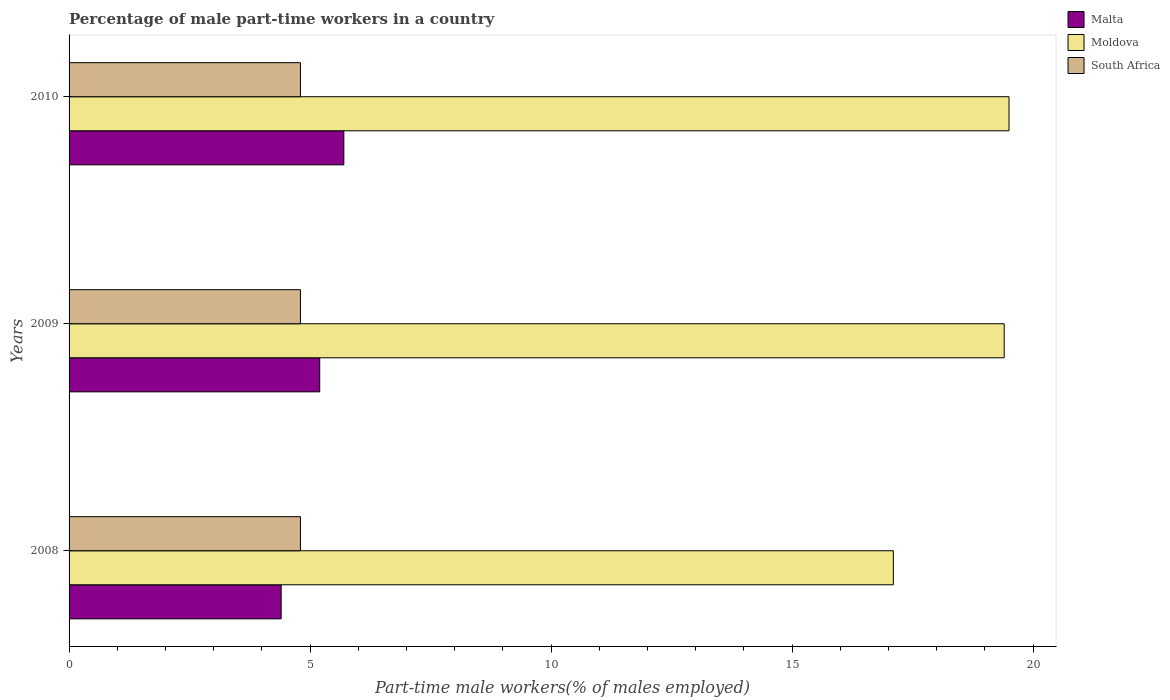How many different coloured bars are there?
Offer a terse response. 3. How many groups of bars are there?
Your answer should be very brief. 3. Are the number of bars per tick equal to the number of legend labels?
Ensure brevity in your answer.  Yes. How many bars are there on the 3rd tick from the top?
Provide a succinct answer. 3. What is the percentage of male part-time workers in Moldova in 2009?
Your response must be concise. 19.4. Across all years, what is the maximum percentage of male part-time workers in Malta?
Provide a succinct answer. 5.7. Across all years, what is the minimum percentage of male part-time workers in Moldova?
Keep it short and to the point. 17.1. In which year was the percentage of male part-time workers in Moldova maximum?
Keep it short and to the point. 2010. What is the total percentage of male part-time workers in Malta in the graph?
Offer a very short reply. 15.3. What is the difference between the percentage of male part-time workers in Moldova in 2008 and that in 2009?
Ensure brevity in your answer.  -2.3. What is the difference between the percentage of male part-time workers in South Africa in 2009 and the percentage of male part-time workers in Moldova in 2008?
Your response must be concise. -12.3. What is the average percentage of male part-time workers in Moldova per year?
Your answer should be very brief. 18.67. In the year 2010, what is the difference between the percentage of male part-time workers in South Africa and percentage of male part-time workers in Moldova?
Make the answer very short. -14.7. What is the ratio of the percentage of male part-time workers in Malta in 2008 to that in 2010?
Your answer should be compact. 0.77. What is the difference between the highest and the lowest percentage of male part-time workers in South Africa?
Keep it short and to the point. 0. In how many years, is the percentage of male part-time workers in Malta greater than the average percentage of male part-time workers in Malta taken over all years?
Make the answer very short. 2. What does the 1st bar from the top in 2009 represents?
Your answer should be compact. South Africa. What does the 1st bar from the bottom in 2010 represents?
Offer a terse response. Malta. Are all the bars in the graph horizontal?
Offer a very short reply. Yes. How many years are there in the graph?
Your response must be concise. 3. Does the graph contain grids?
Your answer should be compact. No. Where does the legend appear in the graph?
Your answer should be very brief. Top right. How are the legend labels stacked?
Give a very brief answer. Vertical. What is the title of the graph?
Your answer should be compact. Percentage of male part-time workers in a country. Does "Costa Rica" appear as one of the legend labels in the graph?
Make the answer very short. No. What is the label or title of the X-axis?
Your answer should be compact. Part-time male workers(% of males employed). What is the Part-time male workers(% of males employed) in Malta in 2008?
Your answer should be very brief. 4.4. What is the Part-time male workers(% of males employed) in Moldova in 2008?
Your answer should be very brief. 17.1. What is the Part-time male workers(% of males employed) in South Africa in 2008?
Your answer should be very brief. 4.8. What is the Part-time male workers(% of males employed) in Malta in 2009?
Keep it short and to the point. 5.2. What is the Part-time male workers(% of males employed) in Moldova in 2009?
Offer a terse response. 19.4. What is the Part-time male workers(% of males employed) of South Africa in 2009?
Offer a terse response. 4.8. What is the Part-time male workers(% of males employed) of Malta in 2010?
Offer a very short reply. 5.7. What is the Part-time male workers(% of males employed) of Moldova in 2010?
Provide a short and direct response. 19.5. What is the Part-time male workers(% of males employed) of South Africa in 2010?
Keep it short and to the point. 4.8. Across all years, what is the maximum Part-time male workers(% of males employed) of Malta?
Keep it short and to the point. 5.7. Across all years, what is the maximum Part-time male workers(% of males employed) in Moldova?
Offer a very short reply. 19.5. Across all years, what is the maximum Part-time male workers(% of males employed) in South Africa?
Your response must be concise. 4.8. Across all years, what is the minimum Part-time male workers(% of males employed) in Malta?
Give a very brief answer. 4.4. Across all years, what is the minimum Part-time male workers(% of males employed) in Moldova?
Give a very brief answer. 17.1. Across all years, what is the minimum Part-time male workers(% of males employed) in South Africa?
Keep it short and to the point. 4.8. What is the total Part-time male workers(% of males employed) of Malta in the graph?
Keep it short and to the point. 15.3. What is the total Part-time male workers(% of males employed) in South Africa in the graph?
Your answer should be compact. 14.4. What is the difference between the Part-time male workers(% of males employed) in Malta in 2008 and that in 2009?
Your response must be concise. -0.8. What is the difference between the Part-time male workers(% of males employed) in Moldova in 2008 and that in 2009?
Offer a very short reply. -2.3. What is the difference between the Part-time male workers(% of males employed) in South Africa in 2008 and that in 2010?
Keep it short and to the point. 0. What is the difference between the Part-time male workers(% of males employed) in Malta in 2009 and that in 2010?
Your answer should be very brief. -0.5. What is the difference between the Part-time male workers(% of males employed) of Moldova in 2009 and that in 2010?
Your answer should be very brief. -0.1. What is the difference between the Part-time male workers(% of males employed) in Malta in 2008 and the Part-time male workers(% of males employed) in South Africa in 2009?
Your response must be concise. -0.4. What is the difference between the Part-time male workers(% of males employed) of Malta in 2008 and the Part-time male workers(% of males employed) of Moldova in 2010?
Offer a terse response. -15.1. What is the difference between the Part-time male workers(% of males employed) in Malta in 2009 and the Part-time male workers(% of males employed) in Moldova in 2010?
Offer a very short reply. -14.3. What is the difference between the Part-time male workers(% of males employed) of Moldova in 2009 and the Part-time male workers(% of males employed) of South Africa in 2010?
Your answer should be very brief. 14.6. What is the average Part-time male workers(% of males employed) of Malta per year?
Your answer should be compact. 5.1. What is the average Part-time male workers(% of males employed) of Moldova per year?
Offer a terse response. 18.67. In the year 2008, what is the difference between the Part-time male workers(% of males employed) in Moldova and Part-time male workers(% of males employed) in South Africa?
Make the answer very short. 12.3. In the year 2009, what is the difference between the Part-time male workers(% of males employed) of Malta and Part-time male workers(% of males employed) of South Africa?
Your answer should be very brief. 0.4. In the year 2010, what is the difference between the Part-time male workers(% of males employed) in Malta and Part-time male workers(% of males employed) in Moldova?
Make the answer very short. -13.8. In the year 2010, what is the difference between the Part-time male workers(% of males employed) in Malta and Part-time male workers(% of males employed) in South Africa?
Offer a terse response. 0.9. What is the ratio of the Part-time male workers(% of males employed) of Malta in 2008 to that in 2009?
Your answer should be very brief. 0.85. What is the ratio of the Part-time male workers(% of males employed) in Moldova in 2008 to that in 2009?
Ensure brevity in your answer.  0.88. What is the ratio of the Part-time male workers(% of males employed) in Malta in 2008 to that in 2010?
Provide a succinct answer. 0.77. What is the ratio of the Part-time male workers(% of males employed) of Moldova in 2008 to that in 2010?
Offer a terse response. 0.88. What is the ratio of the Part-time male workers(% of males employed) in Malta in 2009 to that in 2010?
Provide a succinct answer. 0.91. What is the ratio of the Part-time male workers(% of males employed) in Moldova in 2009 to that in 2010?
Give a very brief answer. 0.99. What is the ratio of the Part-time male workers(% of males employed) of South Africa in 2009 to that in 2010?
Offer a terse response. 1. What is the difference between the highest and the second highest Part-time male workers(% of males employed) of South Africa?
Provide a short and direct response. 0. 